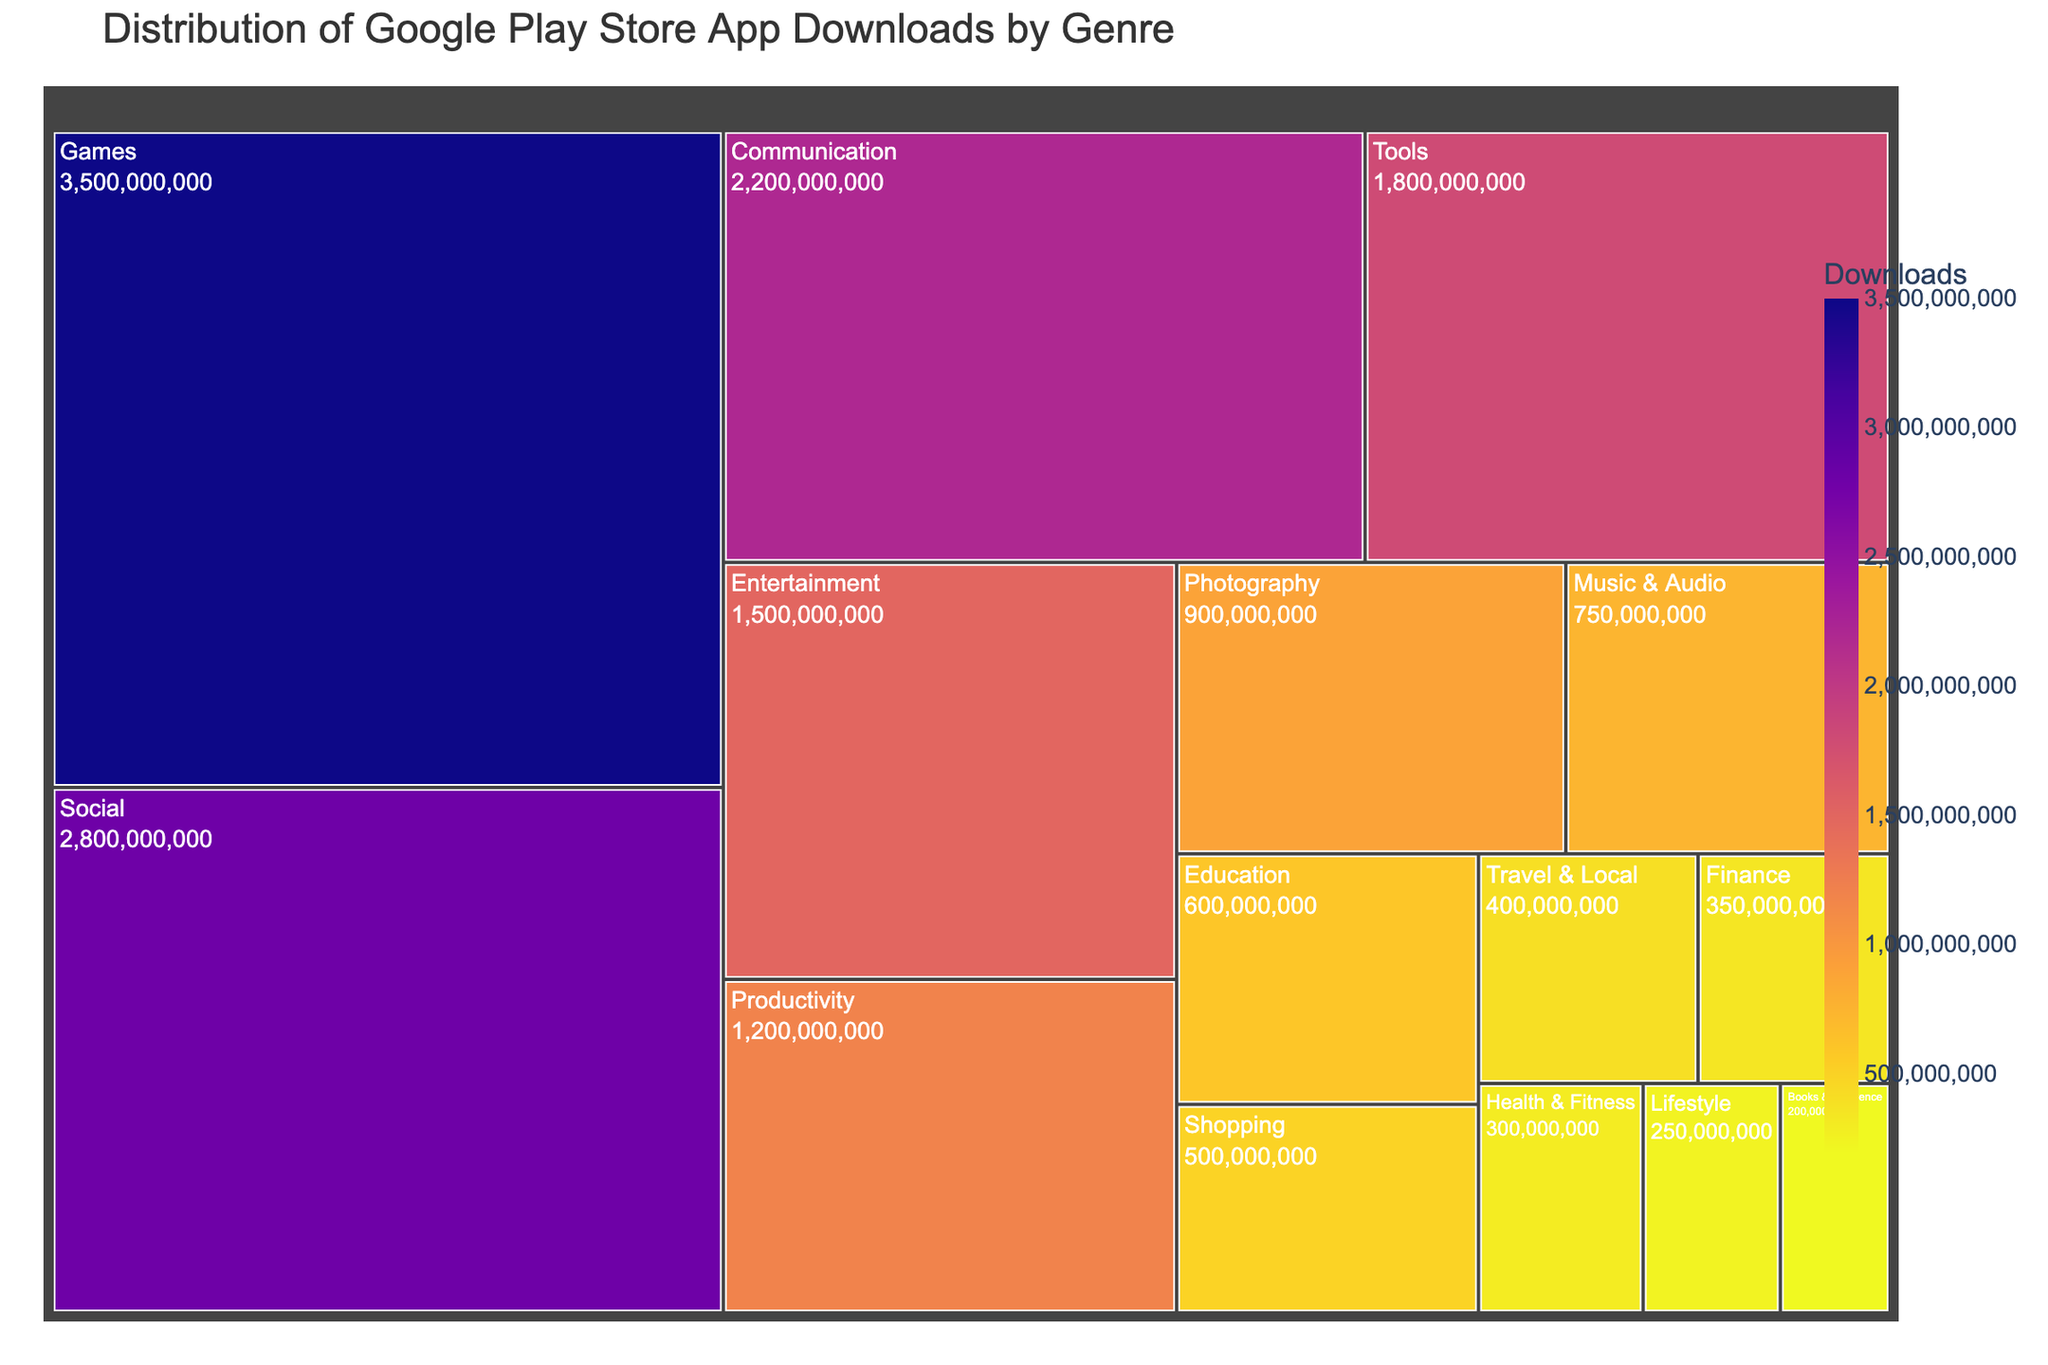What is the title of the treemap? The title of the treemap is usually found at the top of the figure. It gives a brief description of what the figure represents. Here, it is "Distribution of Google Play Store App Downloads by Genre"
Answer: Distribution of Google Play Store App Downloads by Genre Which genre has the highest number of downloads? To find the genre with the highest downloads, look for the largest and typically upper-left section of the treemap since it is often sorted by value. The largest section is "Games" with 3.5 billion downloads.
Answer: Games By how much do the downloads of the "Communication" genre exceed those of the "Productivity" genre? Identify the downloads for "Communication" (2,200,000,000) and "Productivity" (1,200,000,000). Subtract the downloads of "Productivity" from "Communication" to get the difference: 2,200,000,000 - 1,200,000,000 = 1,000,000,000
Answer: 1,000,000,000 What is the total number of downloads for categories with more than 1 billion downloads each? Sum the downloads for the categories "Games" (3,500,000,000), "Social" (2,800,000,000), "Communication" (2,200,000,000), "Tools" (1,800,000,000), and "Entertainment" (1,500,000,000): 3,500,000,000 + 2,800,000,000 + 2,200,000,000 + 1,800,000,000 + 1,500,000,000 = 11,800,000,000
Answer: 11,800,000,000 Which two genres have a similar number of downloads, and what are their download numbers? Scan the treemap for genres with close-sized blocks. "Photography" and "Music & Audio" have similar sizes with download numbers 900,000,000 and 750,000,000 respectively. These are fairly close in magnitude compared to other categories.
Answer: Photography (900,000,000) and Music & Audio (750,000,000) How does the number of downloads in the "Health & Fitness" genre compare to those in the "Finance" genre? Check the figures for "Health & Fitness" (300,000,000) and "Finance" (350,000,000). "Finance" has more downloads than "Health & Fitness".
Answer: Finance > Health & Fitness What categories have fewer than 500,000,000 downloads? Identify the categories with download numbers smaller than 500,000,000 from the treemap: "Travel & Local" (400,000,000), "Finance" (350,000,000), "Health & Fitness" (300,000,000), "Lifestyle" (250,000,000), and "Books & Reference" (200,000,000).
Answer: Travel & Local, Finance, Health & Fitness, Lifestyle, Books & Reference 